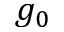Convert formula to latex. <formula><loc_0><loc_0><loc_500><loc_500>g _ { 0 }</formula> 